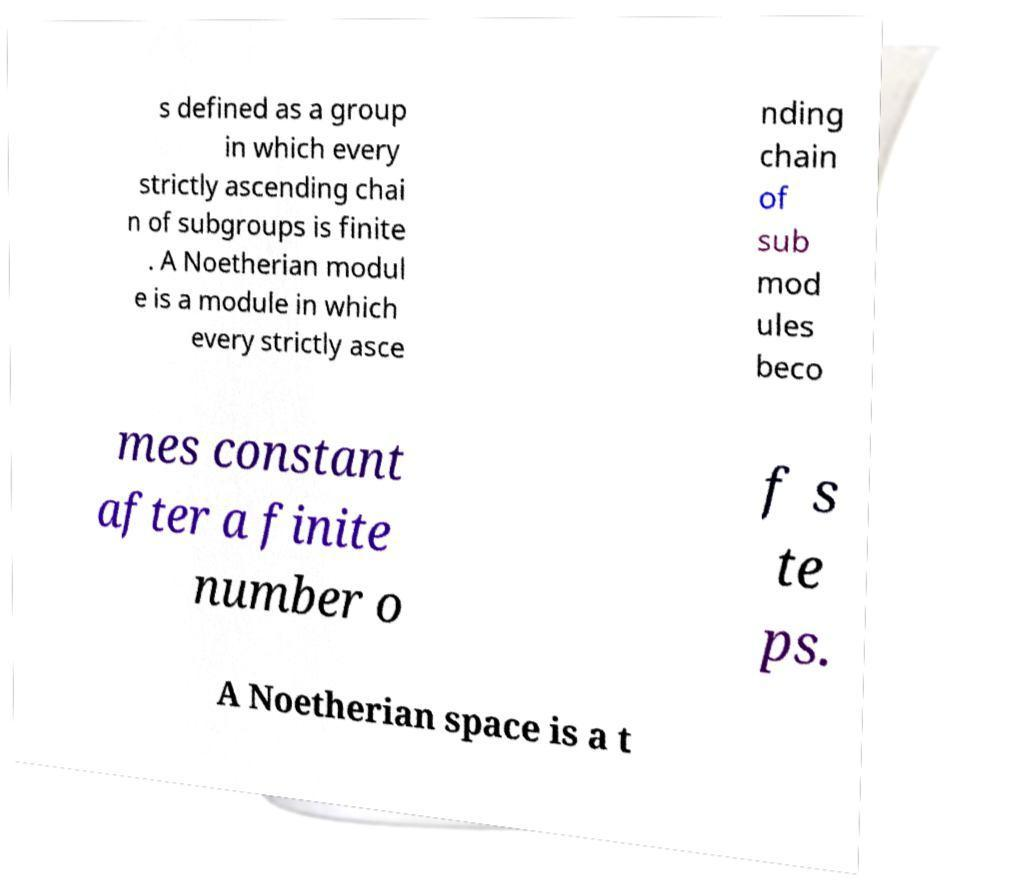Could you extract and type out the text from this image? s defined as a group in which every strictly ascending chai n of subgroups is finite . A Noetherian modul e is a module in which every strictly asce nding chain of sub mod ules beco mes constant after a finite number o f s te ps. A Noetherian space is a t 